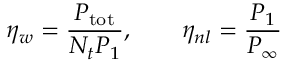Convert formula to latex. <formula><loc_0><loc_0><loc_500><loc_500>\eta _ { w } = \frac { P _ { t o t } } { N _ { t } P _ { 1 } } , \quad \eta _ { n l } = \frac { P _ { 1 } } { P _ { \infty } }</formula> 